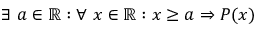Convert formula to latex. <formula><loc_0><loc_0><loc_500><loc_500>\exists a \in \mathbb { R } \colon \forall x \in \mathbb { R } \colon x \geq a \Rightarrow P ( x )</formula> 